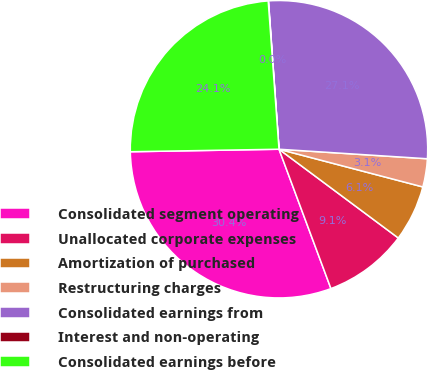Convert chart to OTSL. <chart><loc_0><loc_0><loc_500><loc_500><pie_chart><fcel>Consolidated segment operating<fcel>Unallocated corporate expenses<fcel>Amortization of purchased<fcel>Restructuring charges<fcel>Consolidated earnings from<fcel>Interest and non-operating<fcel>Consolidated earnings before<nl><fcel>30.41%<fcel>9.14%<fcel>6.1%<fcel>3.06%<fcel>27.15%<fcel>0.03%<fcel>24.11%<nl></chart> 